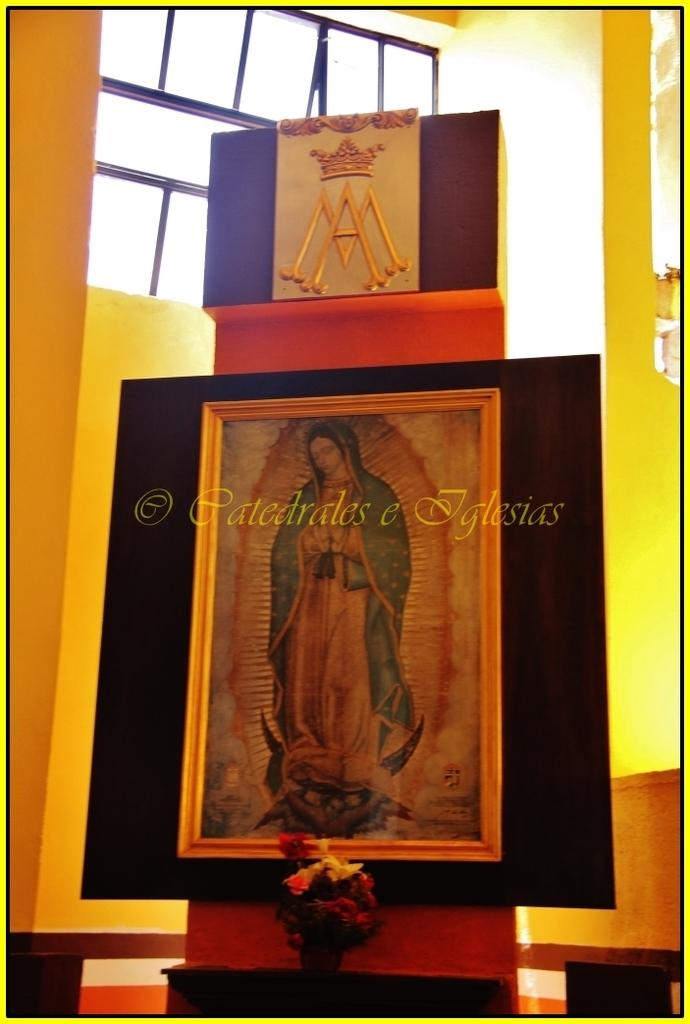<image>
Describe the image concisely. Framed picture of a woman and the name "Patedrales e Iglesias" on top of it. 